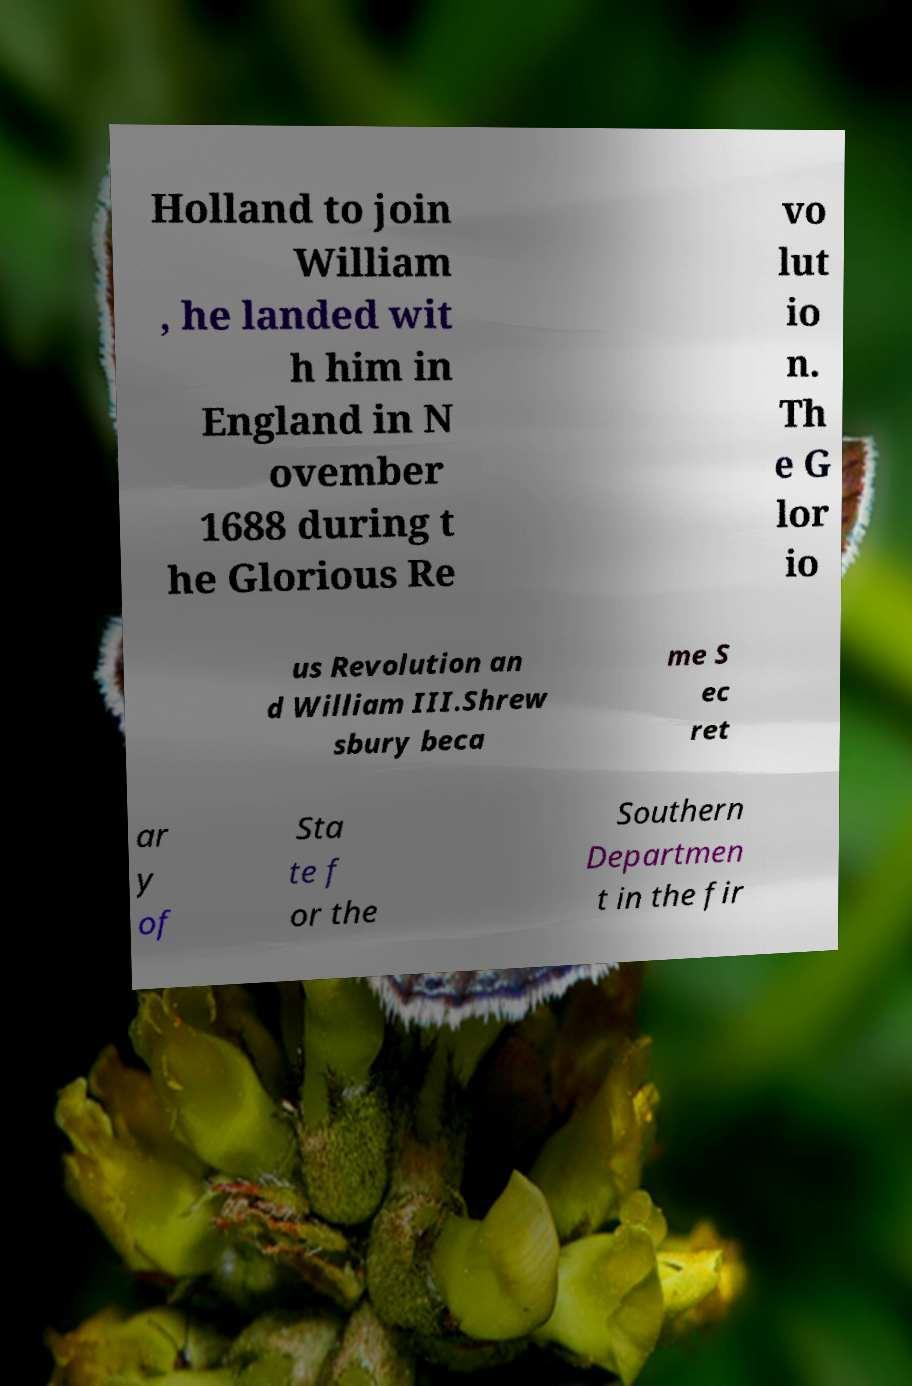Please identify and transcribe the text found in this image. Holland to join William , he landed wit h him in England in N ovember 1688 during t he Glorious Re vo lut io n. Th e G lor io us Revolution an d William III.Shrew sbury beca me S ec ret ar y of Sta te f or the Southern Departmen t in the fir 